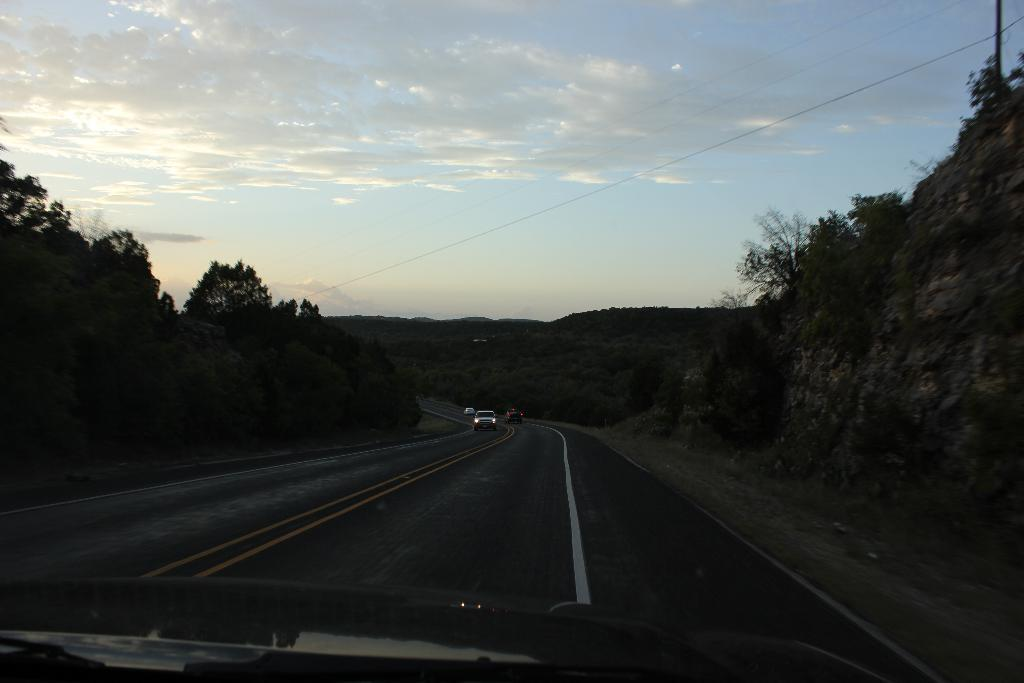What can be seen on the road in the image? There are vehicles on the road in the image. What type of natural scenery is visible in the background? There are trees visible in the background of the image. What is the color of the sky in the image? The sky is blue and white in color. Where is the committee meeting taking place in the image? There is no committee meeting present in the image. Can you see a wall in the image? There is no wall visible in the image. 